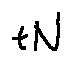<formula> <loc_0><loc_0><loc_500><loc_500>t N</formula> 